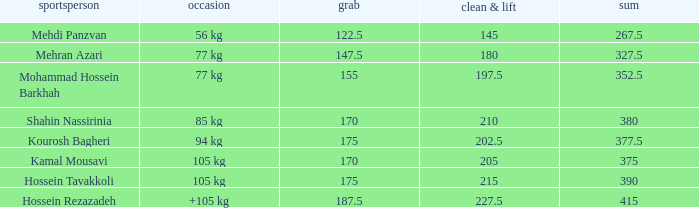Write the full table. {'header': ['sportsperson', 'occasion', 'grab', 'clean & lift', 'sum'], 'rows': [['Mehdi Panzvan', '56 kg', '122.5', '145', '267.5'], ['Mehran Azari', '77 kg', '147.5', '180', '327.5'], ['Mohammad Hossein Barkhah', '77 kg', '155', '197.5', '352.5'], ['Shahin Nassirinia', '85 kg', '170', '210', '380'], ['Kourosh Bagheri', '94 kg', '175', '202.5', '377.5'], ['Kamal Mousavi', '105 kg', '170', '205', '375'], ['Hossein Tavakkoli', '105 kg', '175', '215', '390'], ['Hossein Rezazadeh', '+105 kg', '187.5', '227.5', '415']]} What event has a 122.5 snatch rate? 56 kg. 